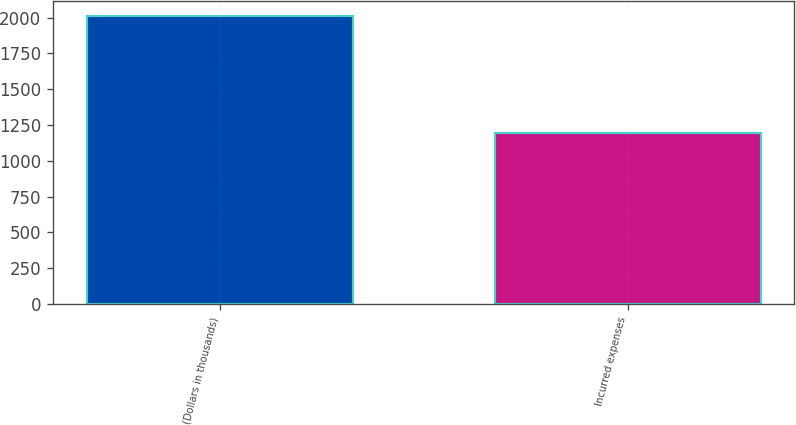Convert chart. <chart><loc_0><loc_0><loc_500><loc_500><bar_chart><fcel>(Dollars in thousands)<fcel>Incurred expenses<nl><fcel>2013<fcel>1195<nl></chart> 